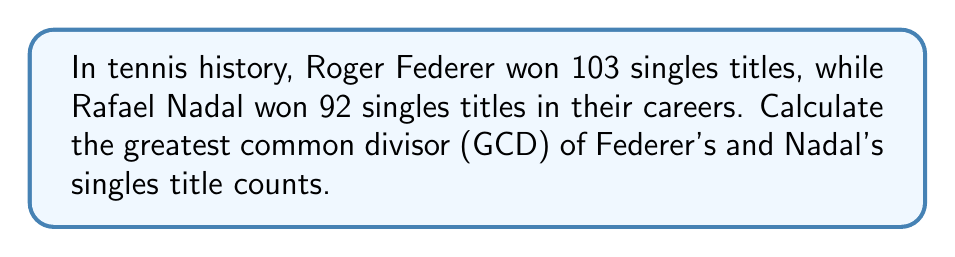Show me your answer to this math problem. To find the greatest common divisor (GCD) of 103 and 92, we'll use the Euclidean algorithm:

1) First, set up the equation:
   $103 = 1 \times 92 + 11$

2) Now, we divide 92 by 11:
   $92 = 8 \times 11 + 4$

3) Next, divide 11 by 4:
   $11 = 2 \times 4 + 3$

4) Then, divide 4 by 3:
   $4 = 1 \times 3 + 1$

5) Finally, divide 3 by 1:
   $3 = 3 \times 1 + 0$

The process stops when we get a remainder of 0. The last non-zero remainder is the GCD.

Therefore, the GCD of 103 and 92 is 1.

This result is interesting for tennis enthusiasts because it shows that Federer's and Nadal's singles title counts are coprime, meaning their greatest common factor is 1. This mathematical curiosity adds another layer to the rivalry between these two tennis legends.
Answer: 1 